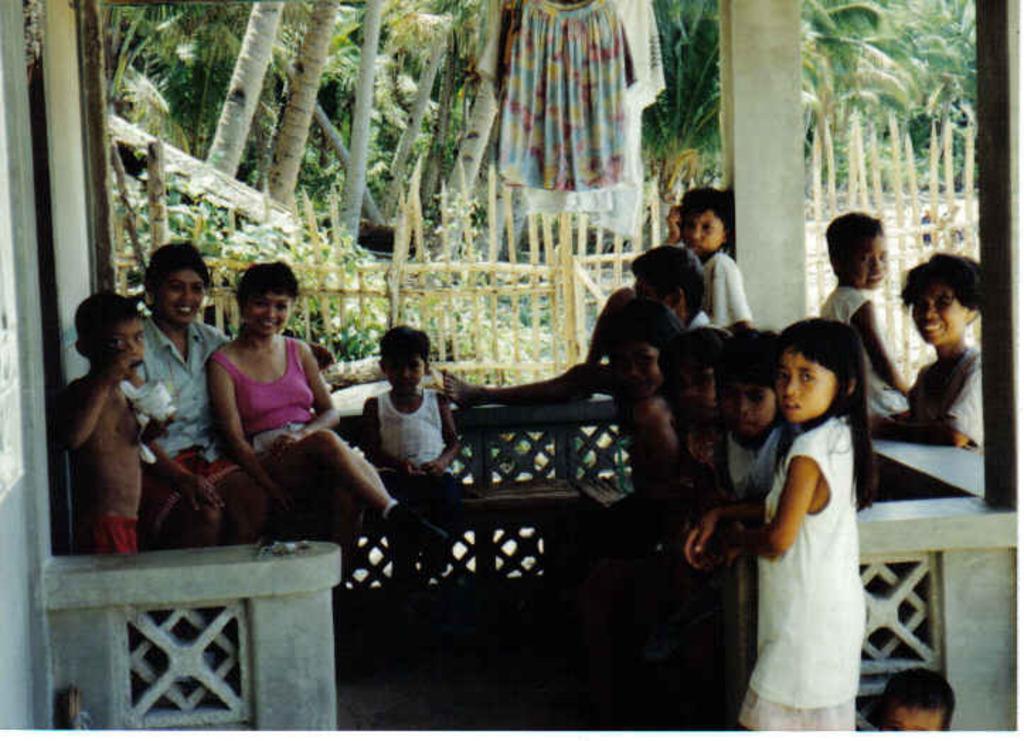Describe this image in one or two sentences. In the given picture, we can see a group of people standing, few are sitting behind the people, we can see some trees and clothes hanging, finally we can see a wooden fencing boundary. 